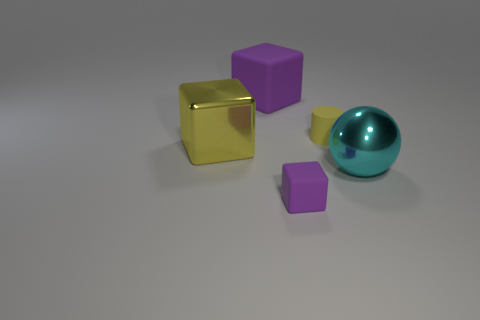There is another cube that is the same color as the tiny block; what is its size?
Provide a succinct answer. Large. Is there a cyan metallic sphere of the same size as the yellow matte thing?
Give a very brief answer. No. The other large object that is the same shape as the large yellow thing is what color?
Keep it short and to the point. Purple. Is there a big sphere behind the big object that is behind the yellow shiny object?
Your response must be concise. No. There is a metal thing that is left of the cyan sphere; is its shape the same as the cyan object?
Provide a succinct answer. No. What shape is the big rubber object?
Make the answer very short. Cube. How many other tiny yellow objects are made of the same material as the small yellow object?
Provide a short and direct response. 0. Does the small cylinder have the same color as the large cube behind the metal cube?
Offer a very short reply. No. How many tiny gray things are there?
Give a very brief answer. 0. Are there any cubes of the same color as the large matte object?
Offer a very short reply. Yes. 